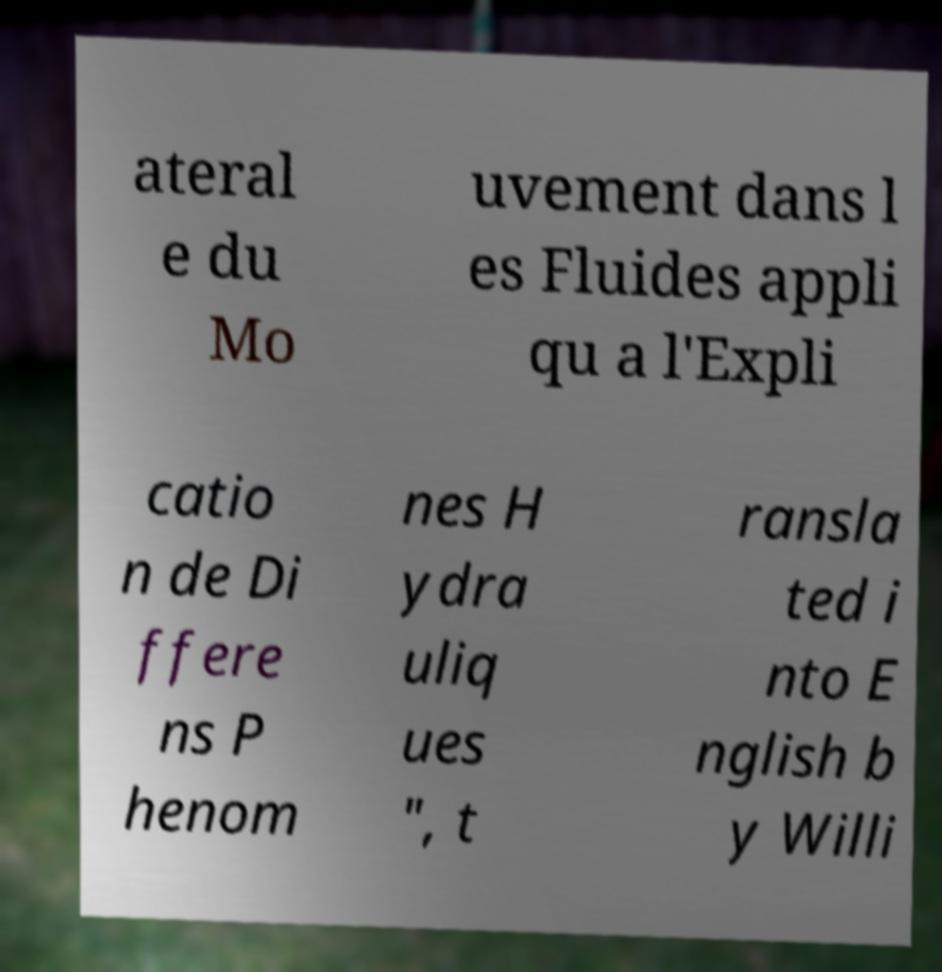Please identify and transcribe the text found in this image. ateral e du Mo uvement dans l es Fluides appli qu a l'Expli catio n de Di ffere ns P henom nes H ydra uliq ues ", t ransla ted i nto E nglish b y Willi 